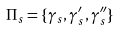<formula> <loc_0><loc_0><loc_500><loc_500>\Pi _ { s } = \{ \gamma _ { s } , \gamma ^ { \prime } _ { s } , \gamma ^ { \prime \prime } _ { s } \}</formula> 